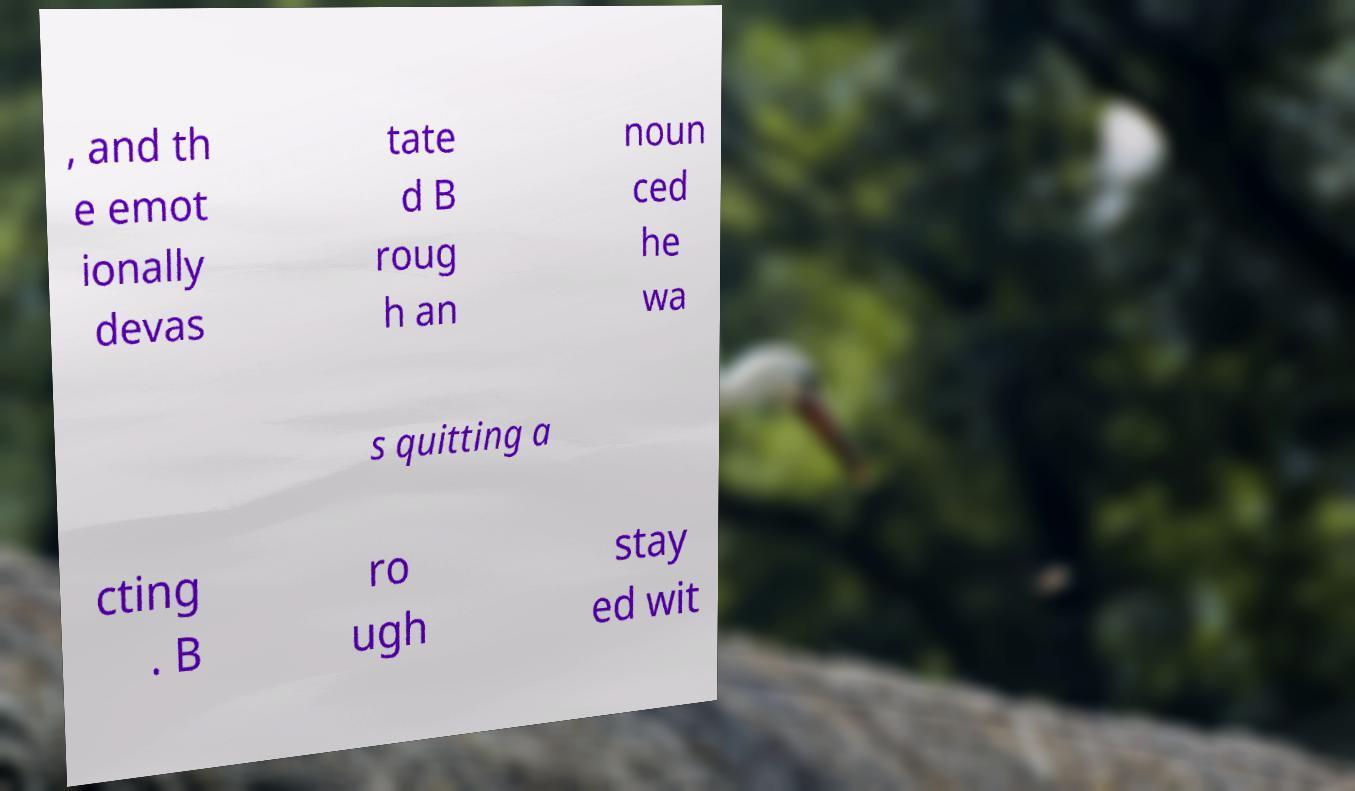Please identify and transcribe the text found in this image. , and th e emot ionally devas tate d B roug h an noun ced he wa s quitting a cting . B ro ugh stay ed wit 